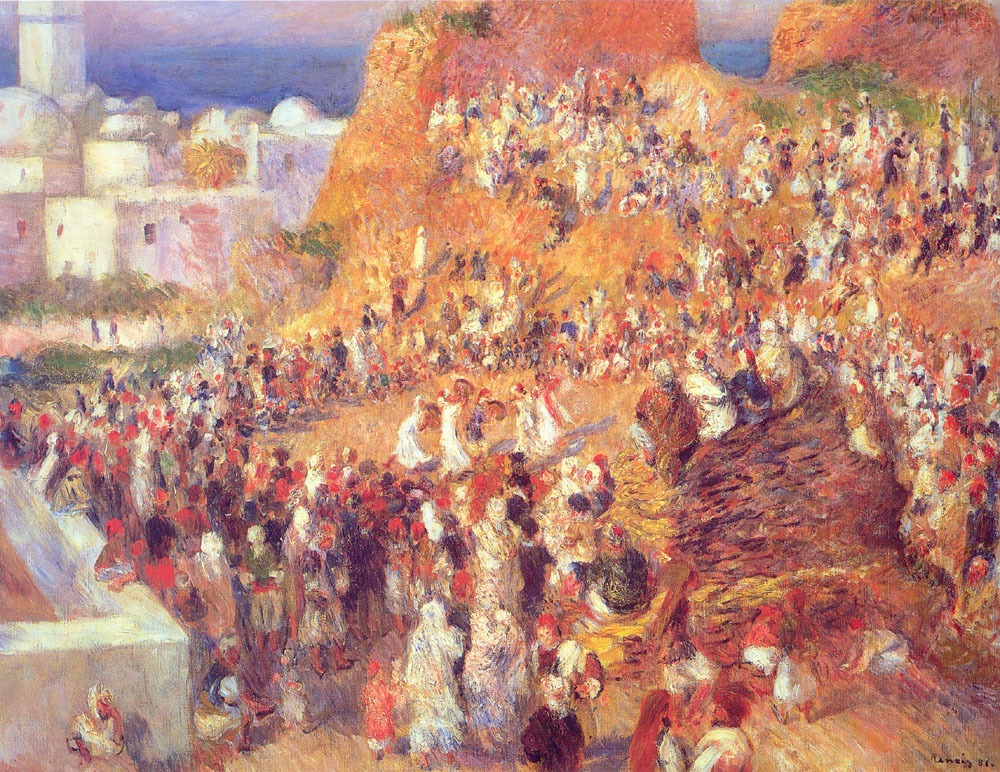Create a story based on a character in this painting. In the midst of the lively market scene, a young woman named Isabella moves gracefully between the colorful stalls. Her eyes, sparkling with curiosity, take in the vibrant array of spices, fabrics, and trinkets. Isabella has lived in this town all her life, and the market is her second home. As the daughter of a potter, she often helps her father sell his beautifully crafted ceramics. Today, however, is different. Isabella has a secret dream to become a painter, much like the one who created this very scene. In her spare moments, she sketches the bustling life around her, capturing the essence of the market's energy and joy. Her sketchbook, tucked securely in her satchel, is filled with scenes of daily life, each stroke a testament to her passion. One day, as she draws a particularly vibrant stall, a renowned artist notices her talent and offers to take her on as an apprentice. This chance encounter opens up a world of opportunity for Isabella, allowing her to turn her dreams into reality while still cherishing the market that has been her muse. 